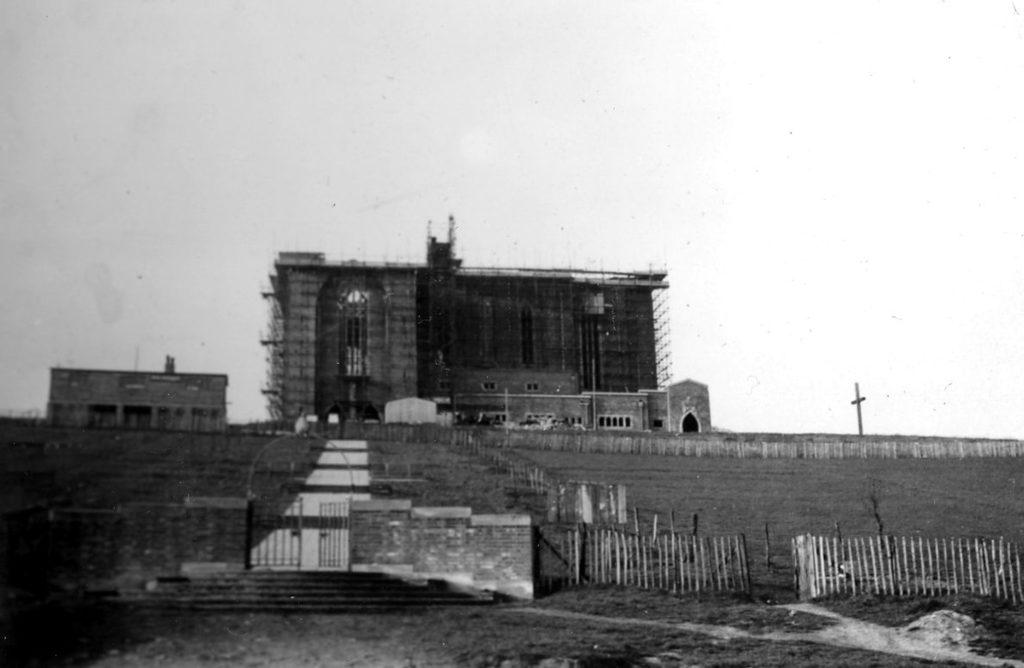What type of structure can be seen in the image? There is a building in the image. What symbol is present on the path in the image? There is a cross sign on the path. What is the entrance to the building like in the image? A gate is visible in the image. Are there any architectural features that allow access to the building? Yes, there are stairs in the image. What type of fencing is present in the image? There is wooden fencing in the image. What type of vegetation can be seen on the ground in the image? Some grass is visible on the ground. What type of trade is being conducted in the image? There is no indication of any trade being conducted in the image. Can you see any aircraft in the image? There is no mention of any aircraft or flight-related elements in the image. 